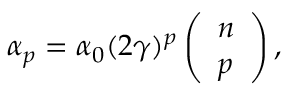Convert formula to latex. <formula><loc_0><loc_0><loc_500><loc_500>\alpha _ { p } = \alpha _ { 0 } ( 2 \gamma ) ^ { p } \left ( \begin{array} { c } { n } \\ { p } \end{array} \right ) ,</formula> 